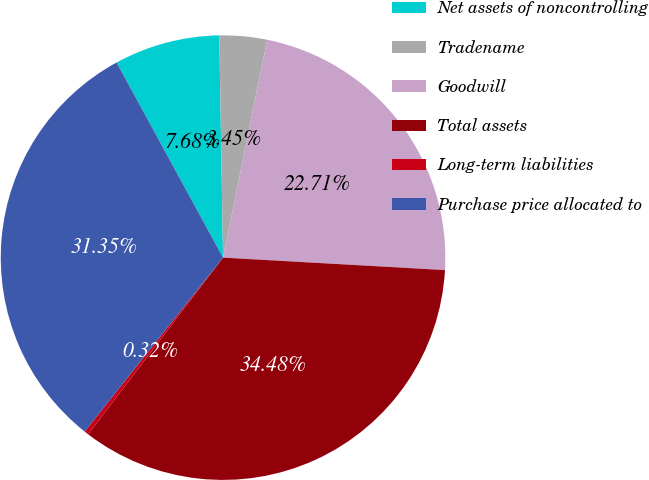<chart> <loc_0><loc_0><loc_500><loc_500><pie_chart><fcel>Net assets of noncontrolling<fcel>Tradename<fcel>Goodwill<fcel>Total assets<fcel>Long-term liabilities<fcel>Purchase price allocated to<nl><fcel>7.68%<fcel>3.45%<fcel>22.71%<fcel>34.48%<fcel>0.32%<fcel>31.35%<nl></chart> 